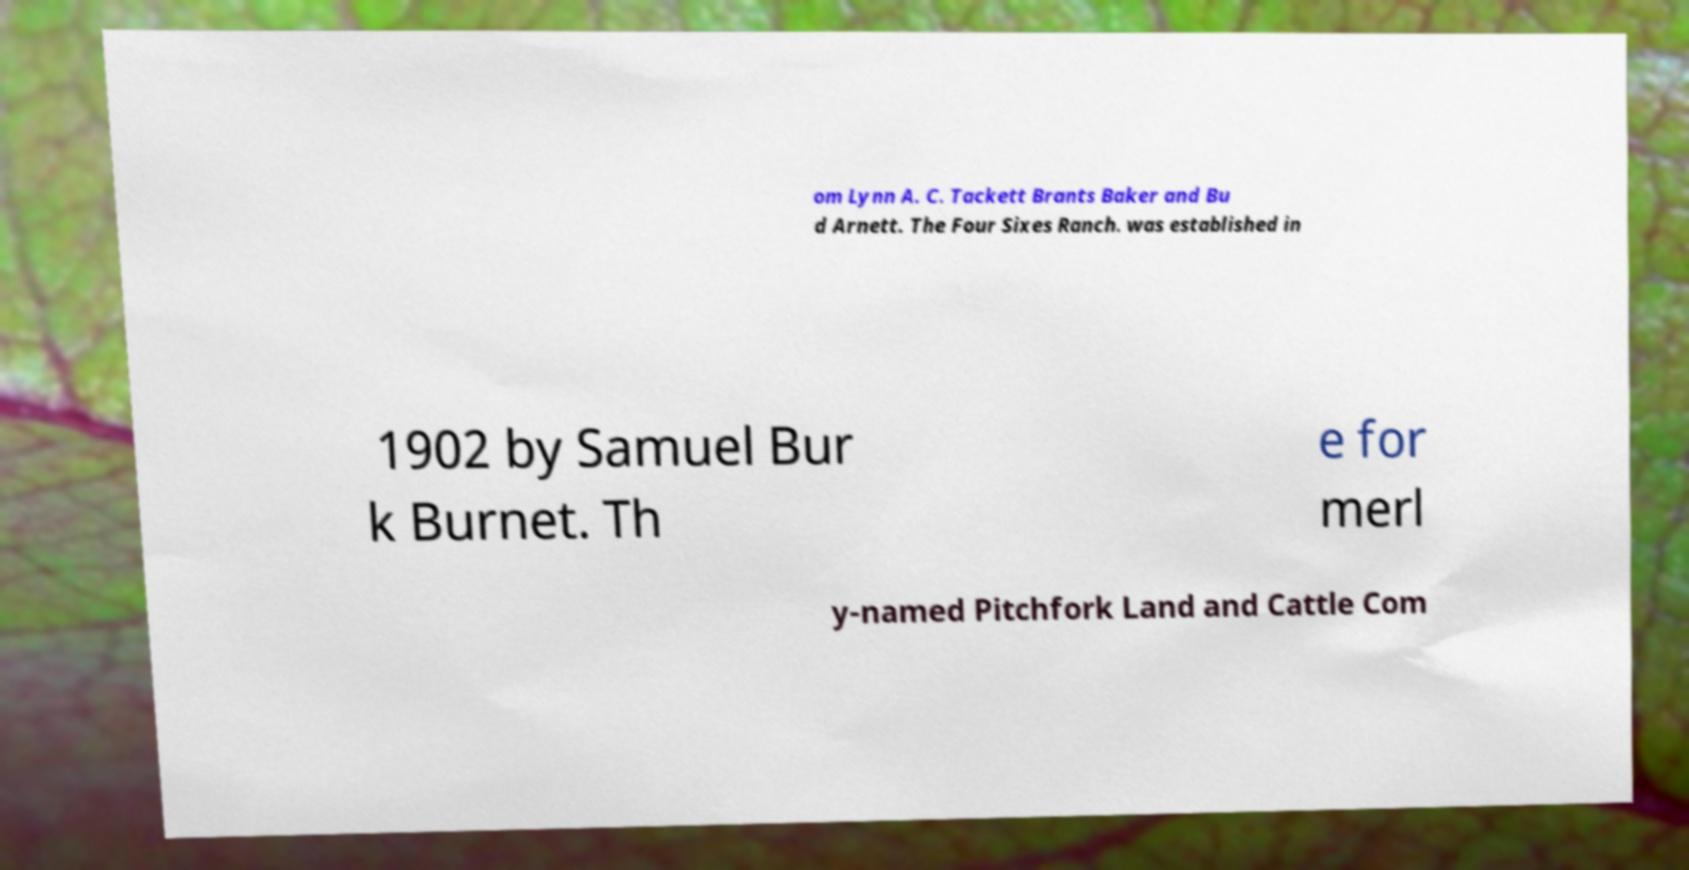Can you read and provide the text displayed in the image?This photo seems to have some interesting text. Can you extract and type it out for me? om Lynn A. C. Tackett Brants Baker and Bu d Arnett. The Four Sixes Ranch. was established in 1902 by Samuel Bur k Burnet. Th e for merl y-named Pitchfork Land and Cattle Com 